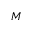<formula> <loc_0><loc_0><loc_500><loc_500>M</formula> 